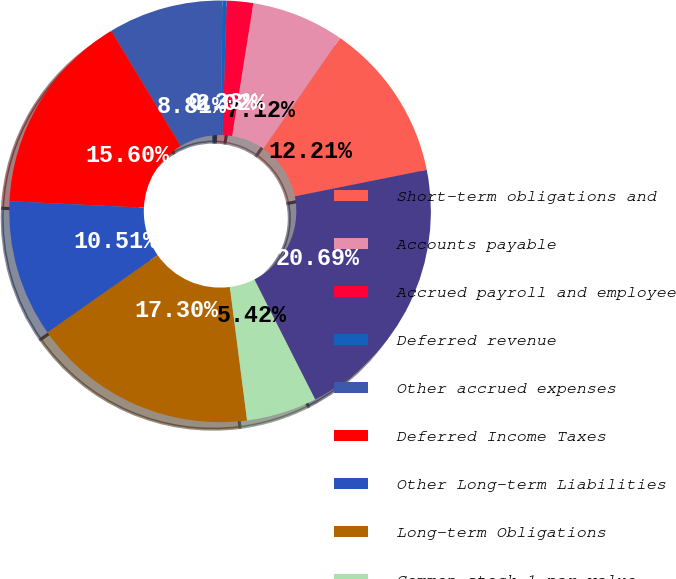Convert chart to OTSL. <chart><loc_0><loc_0><loc_500><loc_500><pie_chart><fcel>Short-term obligations and<fcel>Accounts payable<fcel>Accrued payroll and employee<fcel>Deferred revenue<fcel>Other accrued expenses<fcel>Deferred Income Taxes<fcel>Other Long-term Liabilities<fcel>Long-term Obligations<fcel>Common stock 1 par value<fcel>Capital in excess of par value<nl><fcel>12.21%<fcel>7.12%<fcel>2.02%<fcel>0.33%<fcel>8.81%<fcel>15.6%<fcel>10.51%<fcel>17.3%<fcel>5.42%<fcel>20.69%<nl></chart> 